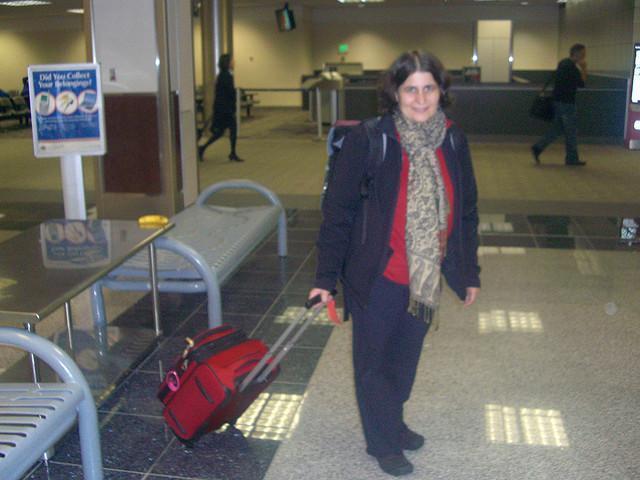How many people are visible?
Give a very brief answer. 3. How many benches are visible?
Give a very brief answer. 2. 